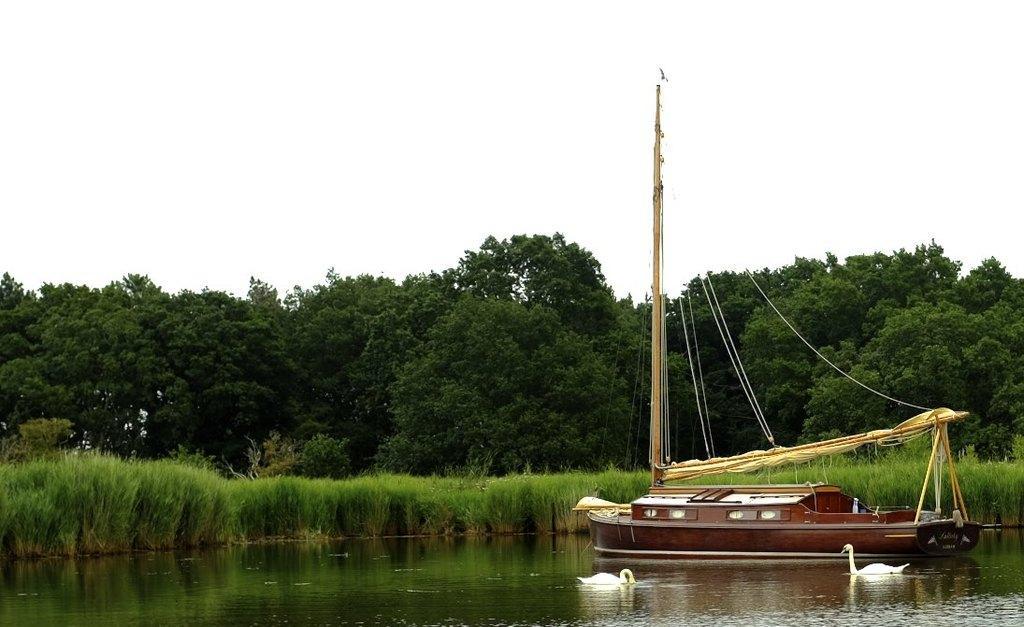How would you summarize this image in a sentence or two? On the right side of the image, we can see a boat is there above the water. Here we can see two swans in the water. Background we can see plants, trees and sky. Here a bird is flying in the air. 